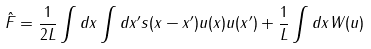Convert formula to latex. <formula><loc_0><loc_0><loc_500><loc_500>\hat { F } = \frac { 1 } { 2 L } \int d x \int d x ^ { \prime } s ( x - x ^ { \prime } ) u ( x ) u ( x ^ { \prime } ) + \frac { 1 } { L } \int d x W ( u )</formula> 